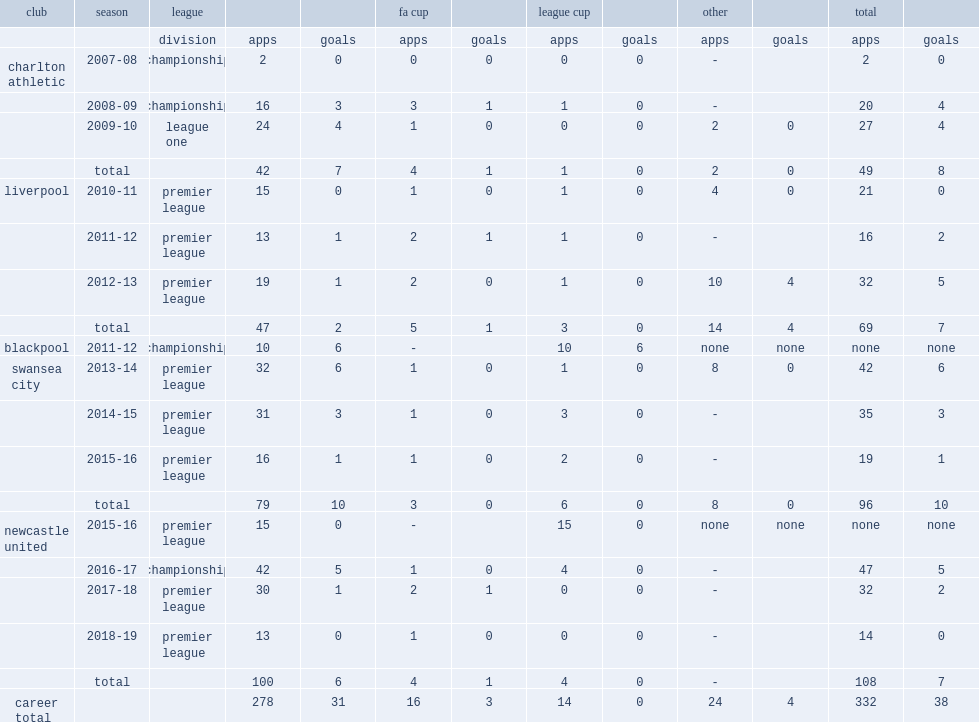In 2012, which club did jonjo shelvey appear in the league cup and the fa cup? Liverpool. 